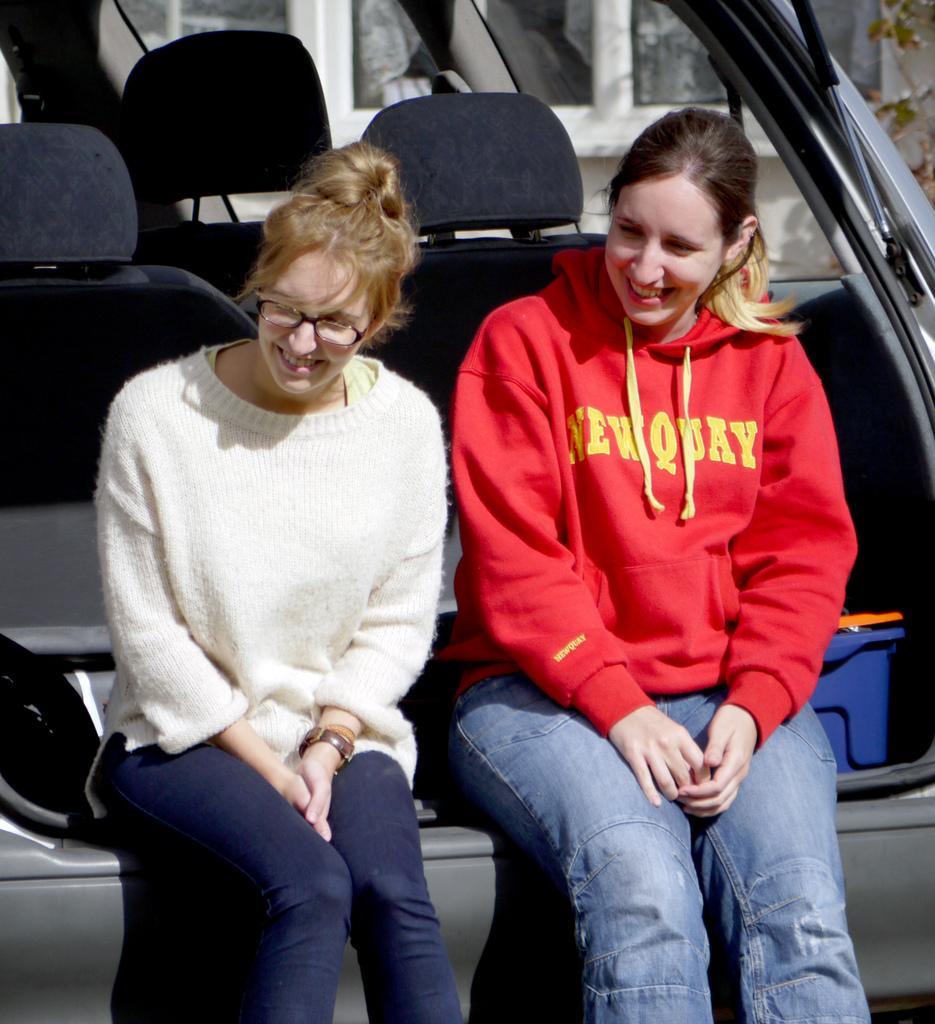Please provide a concise description of this image. In this picture we can see two woman sitting at back of vehicle and smiling and beside to them we can see windows, tree, basket. 